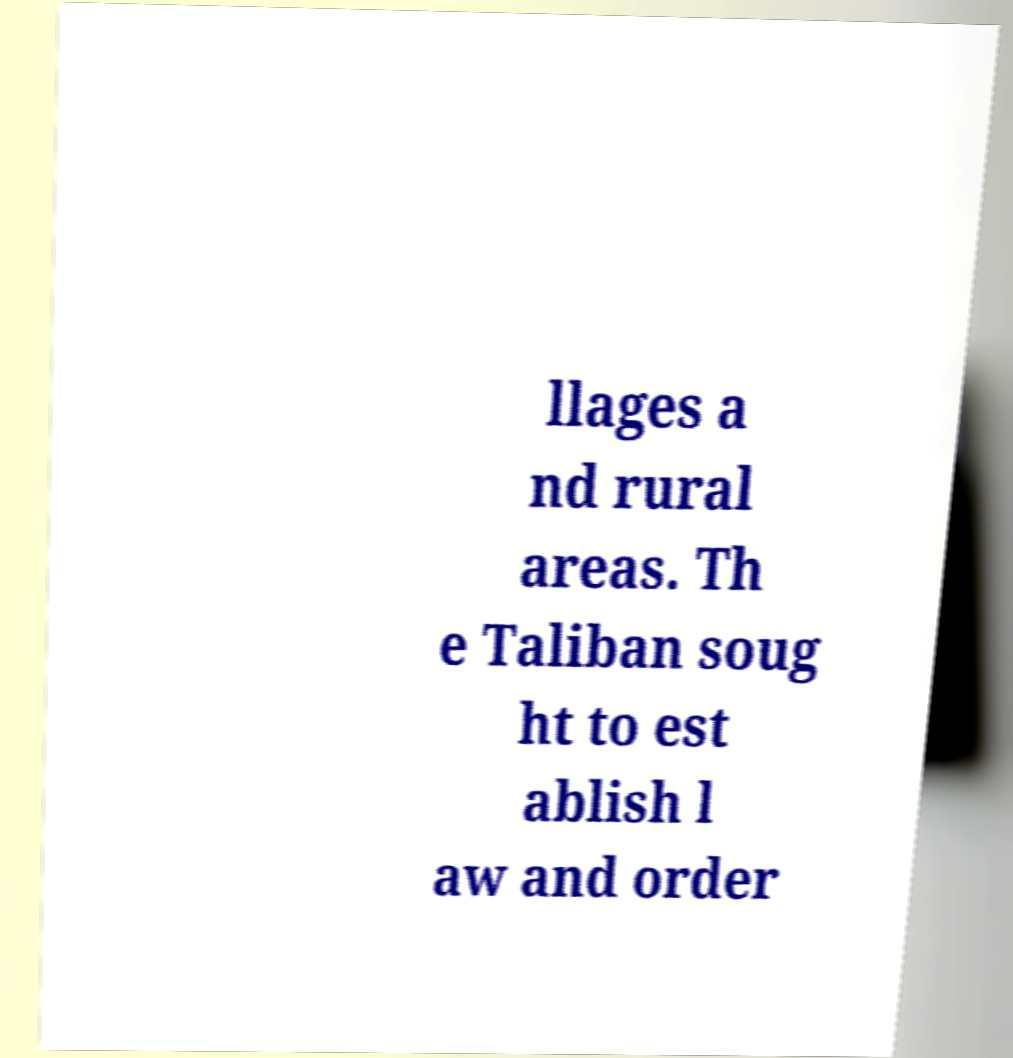I need the written content from this picture converted into text. Can you do that? llages a nd rural areas. Th e Taliban soug ht to est ablish l aw and order 